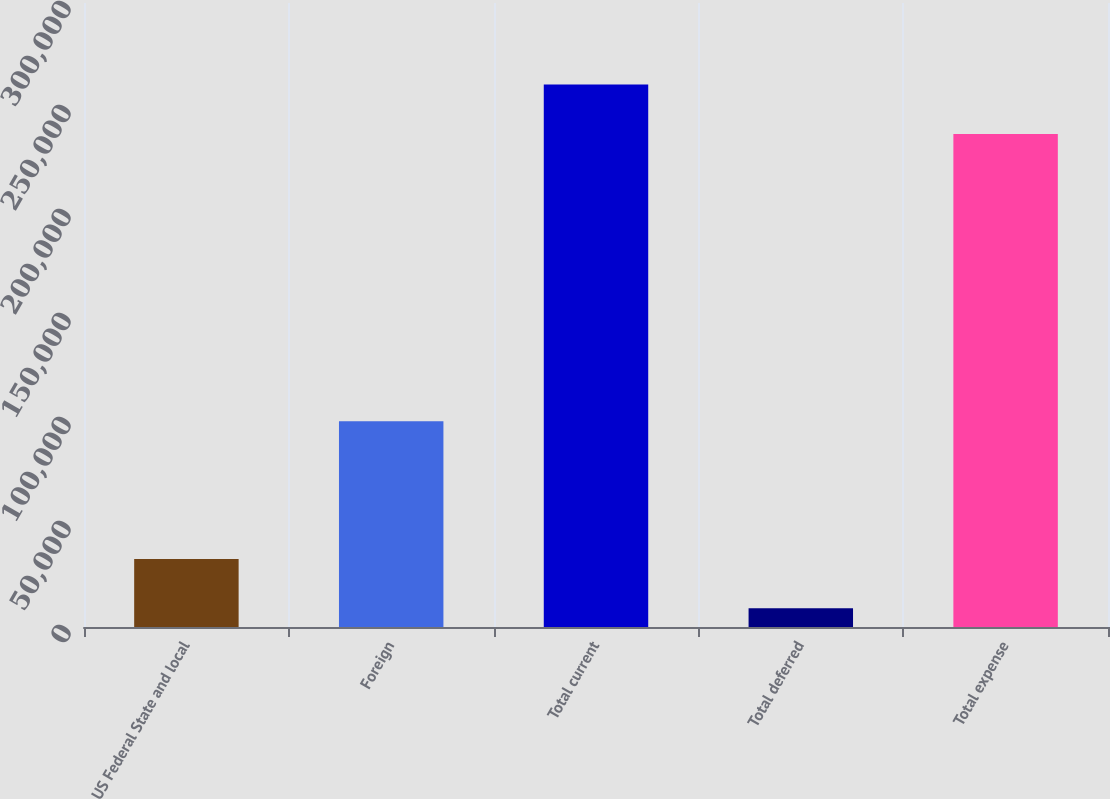Convert chart to OTSL. <chart><loc_0><loc_0><loc_500><loc_500><bar_chart><fcel>US Federal State and local<fcel>Foreign<fcel>Total current<fcel>Total deferred<fcel>Total expense<nl><fcel>32742.6<fcel>98919<fcel>260784<fcel>9035<fcel>237076<nl></chart> 